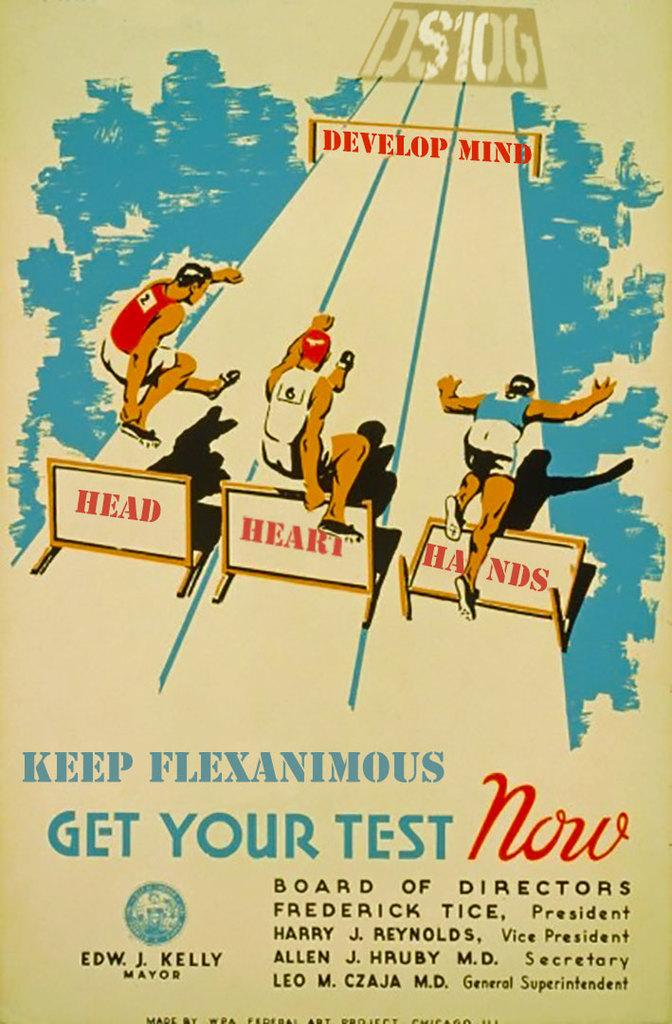<image>
Create a compact narrative representing the image presented. Three men are racing to develop their minds. 